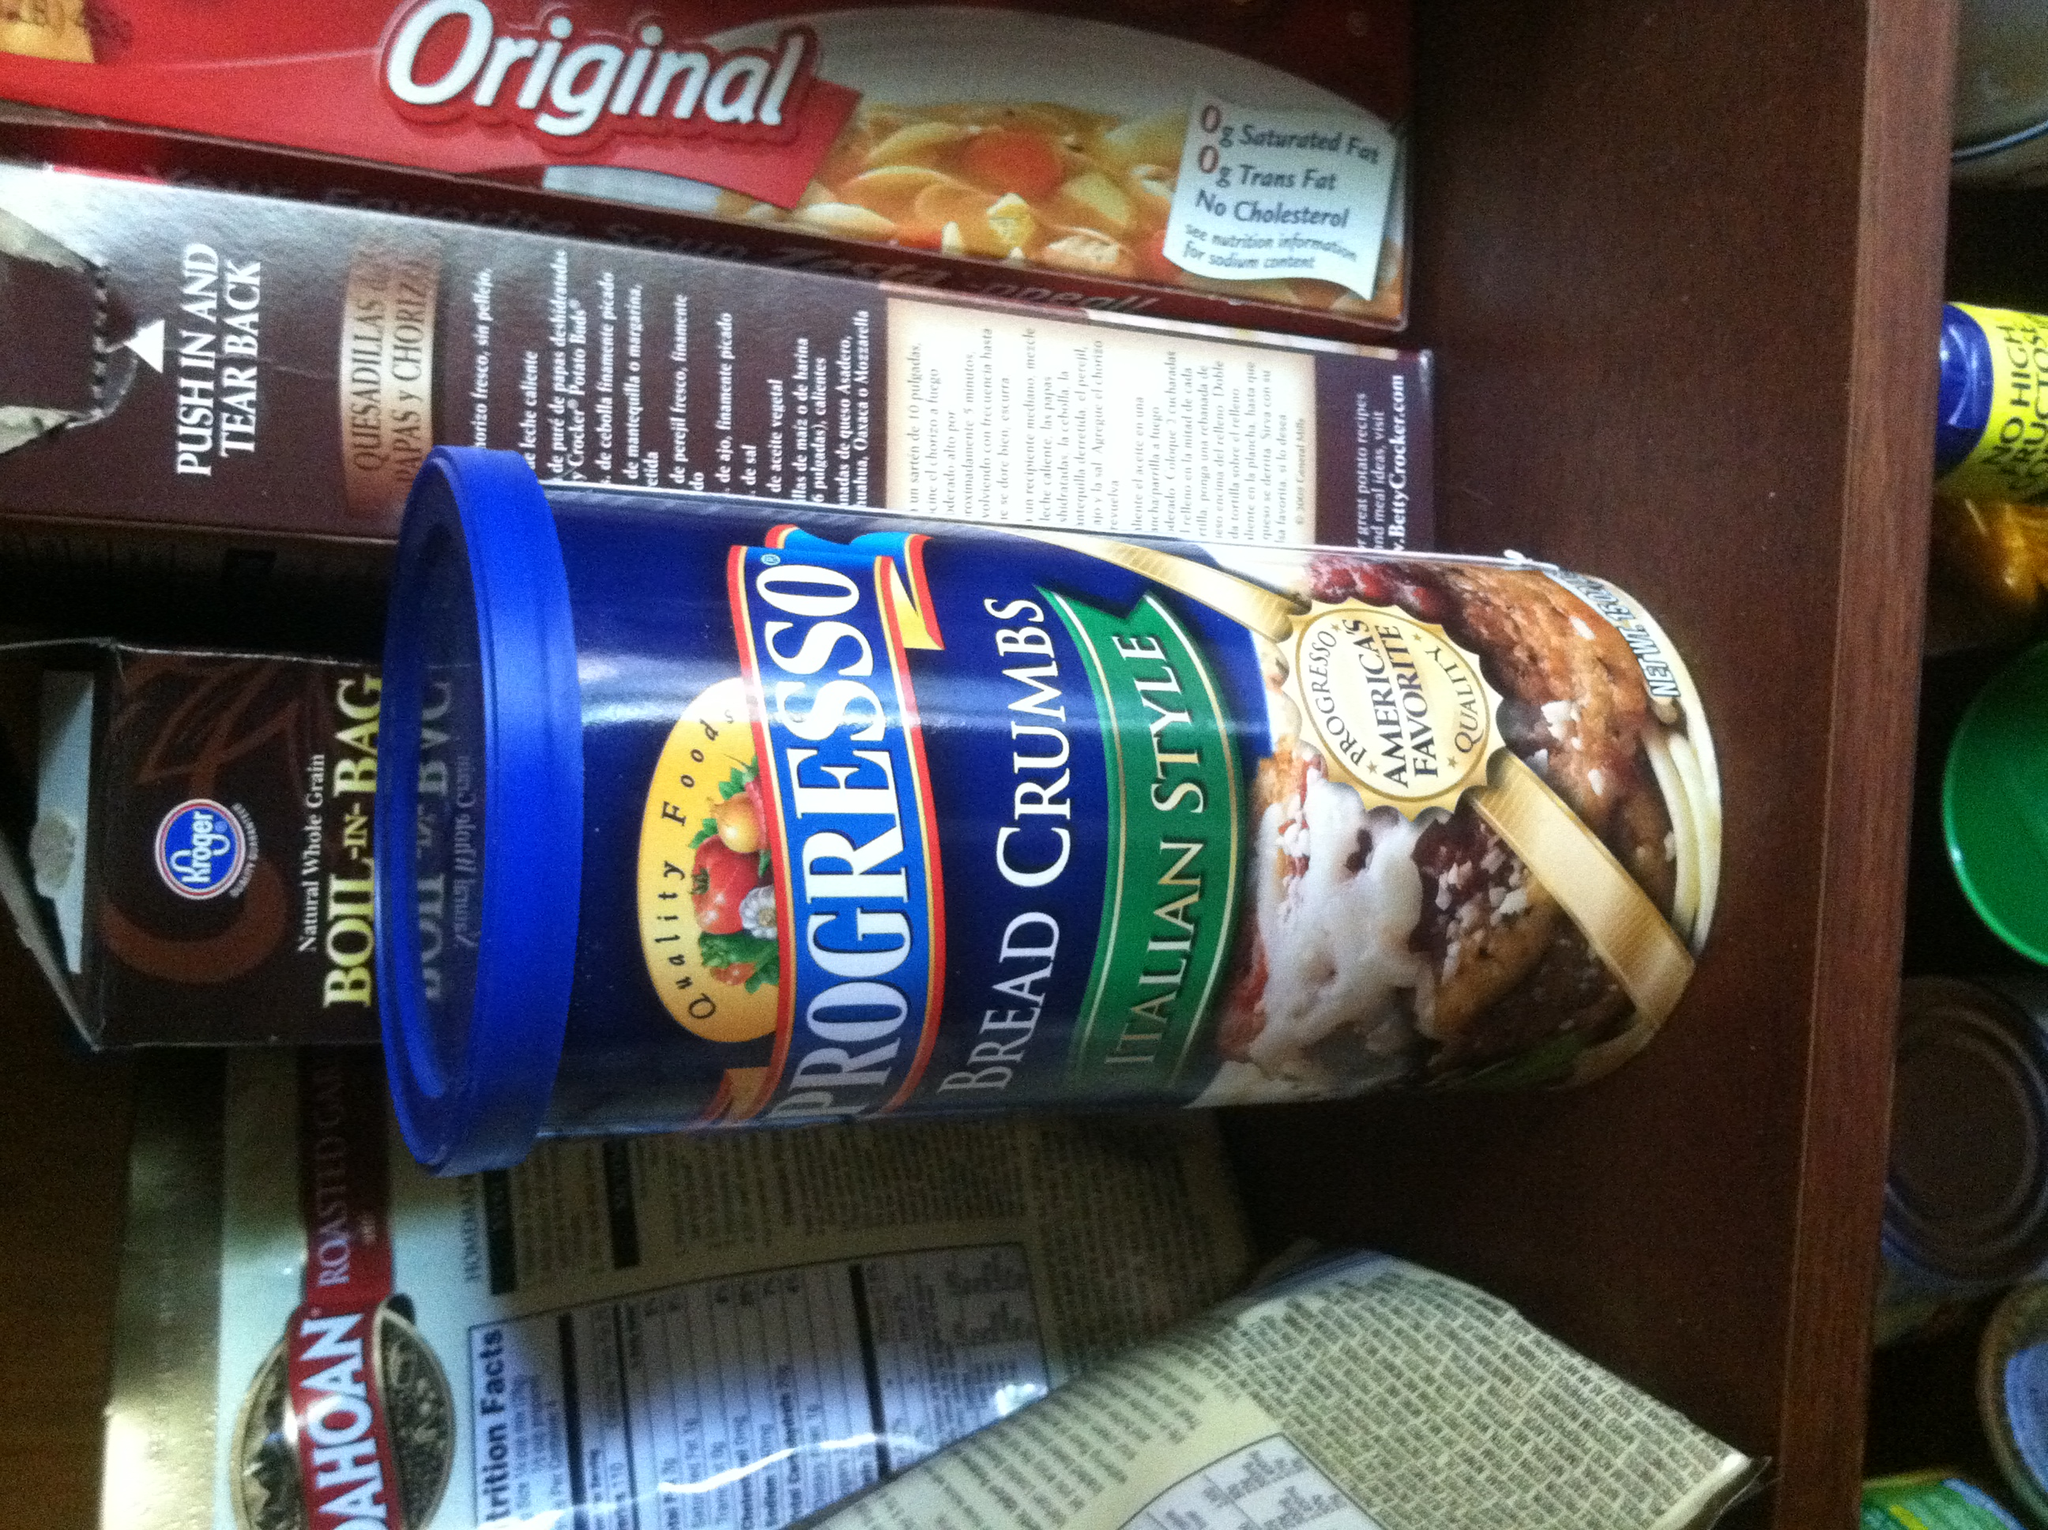Can you tell me more about the product in the blue can? Certainly! The product in the blue can is Progresso Bread Crumbs, specifically the Italian Style variety. These bread crumbs are flavored with Italian herbs and seasonings, making them perfect for adding a touch of Italian cuisine to various dishes like chicken parmesan, meatballs, or eggplant parmesan. The label also mentions that it is a preferred choice due to its quality and taste. What dishes can I make using these bread crumbs? There are a multitude of dishes that can benefit from the rich flavor of Italian style bread crumbs. You could use them to make a delicious chicken parmesan by breading the chicken cutlets, frying them, and then baking them with marinara sauce and melted cheese. Another popular option is to incorporate them into meatballs, combining ground meat with the breadcrumbs, egg, and seasonings before cooking. For a vegetarian option, you can use these bread crumbs to coat slices of eggplant for eggplant parmesan. Additionally, they can be used as a flavorful topping for baked casseroles, adding a pleasing crunchy texture. Is there a creative way to use bread crumbs that might surprise people? Absolutely! Here's a creative and somewhat surprising use: you can use these bread crumbs to create a savory, crunchy topping for your mac and cheese. After preparing the mac and cheese, sprinkle a generous amount of bread crumbs mixed with grated cheese and a little bit of melted butter over the top, then bake until golden brown. This results in a delightful contrast between the creamy pasta and the crunchy topping, sure to impress your guests! 